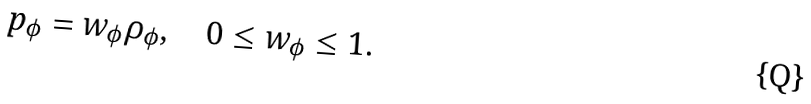Convert formula to latex. <formula><loc_0><loc_0><loc_500><loc_500>p _ { \phi } = w _ { \phi } \rho _ { \phi } , \quad 0 \leq w _ { \phi } \leq 1 .</formula> 